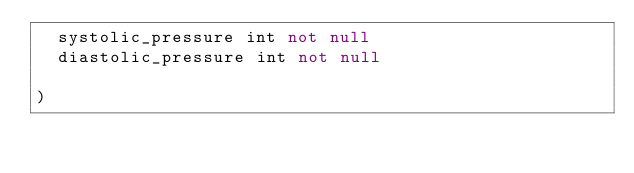Convert code to text. <code><loc_0><loc_0><loc_500><loc_500><_SQL_>  systolic_pressure int not null
  diastolic_pressure int not null

)

</code> 